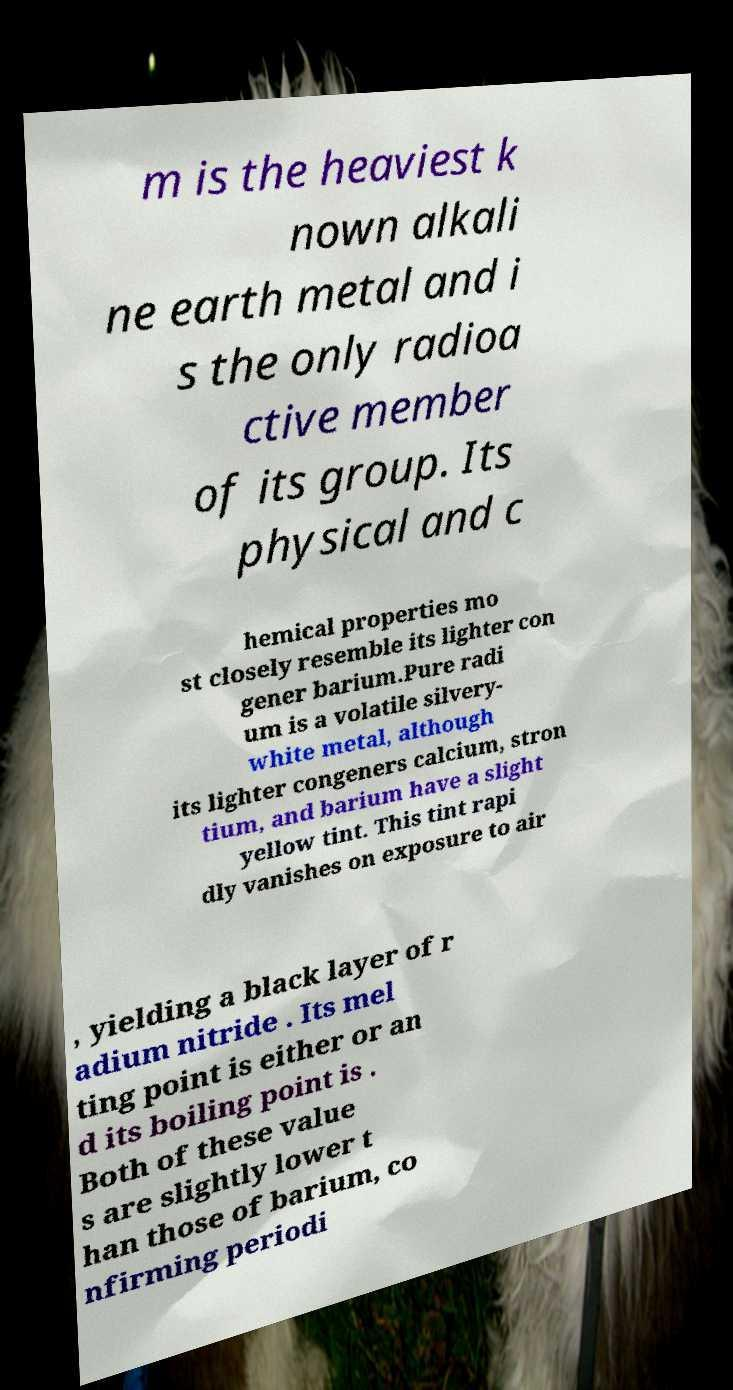Can you read and provide the text displayed in the image?This photo seems to have some interesting text. Can you extract and type it out for me? m is the heaviest k nown alkali ne earth metal and i s the only radioa ctive member of its group. Its physical and c hemical properties mo st closely resemble its lighter con gener barium.Pure radi um is a volatile silvery- white metal, although its lighter congeners calcium, stron tium, and barium have a slight yellow tint. This tint rapi dly vanishes on exposure to air , yielding a black layer of r adium nitride . Its mel ting point is either or an d its boiling point is . Both of these value s are slightly lower t han those of barium, co nfirming periodi 